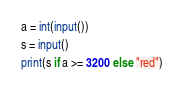Convert code to text. <code><loc_0><loc_0><loc_500><loc_500><_Python_>a = int(input())
s = input()
print(s if a >= 3200 else "red")</code> 